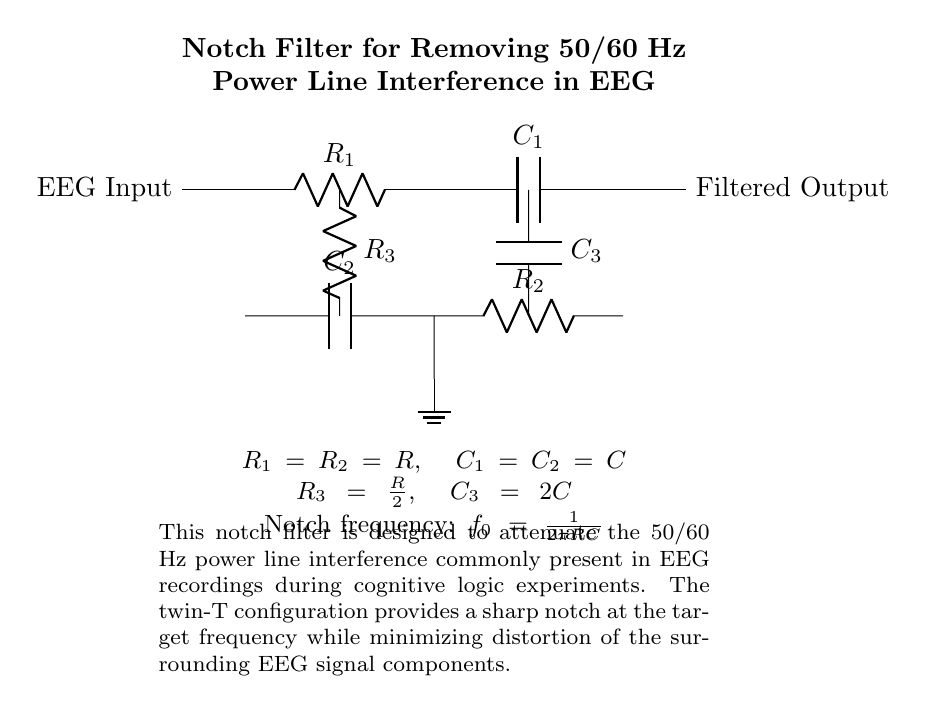What type of filter is depicted in the circuit? The circuit is a notch filter, as indicated by its design which specifically aims to eliminate certain frequencies. The title of the circuit references a notch filter used for power line interference removal.
Answer: Notch filter What is the notch frequency of the circuit? The notch frequency is calculated using the formula given in the circuit diagram. It is defined as \( f_0 = \frac{1}{2\pi RC} \), indicating the frequency at which the circuit provides attenuation. The specific values for R and C lead to this defined notch frequency characteristic of the filter.
Answer: One over two pi R C What are the values of R and C in the circuit? The circuit states that \( R_1 = R_2 = R \) and \( C_1 = C_2 = C \). These components share the same resistance and capacitance values, providing a uniform characteristic essential for the notch filter's operation.
Answer: R and C How many resistors are in the circuit? The overhead display of components reveals three resistors: R1, R2, and R3. This total can be counted directly from the circuit diagram components.
Answer: Three resistors What is the purpose of the capacitor C3? Capacitor C3 is part of the twin-T configuration in this notch filter; it has a value of \( 2C \) and works with the resistors and other capacitors to establish a notch at the desired frequency, contributing to frequency selective response to filter out interference.
Answer: Establish notch frequency What configuration is used in the notch filter? The circuit utilizes a twin-T configuration, which involves a specific arrangement of resistors and capacitors to achieve the desired frequency response characteristic of the notch filter. This is particularly noted in the design structure.
Answer: Twin-T configuration 